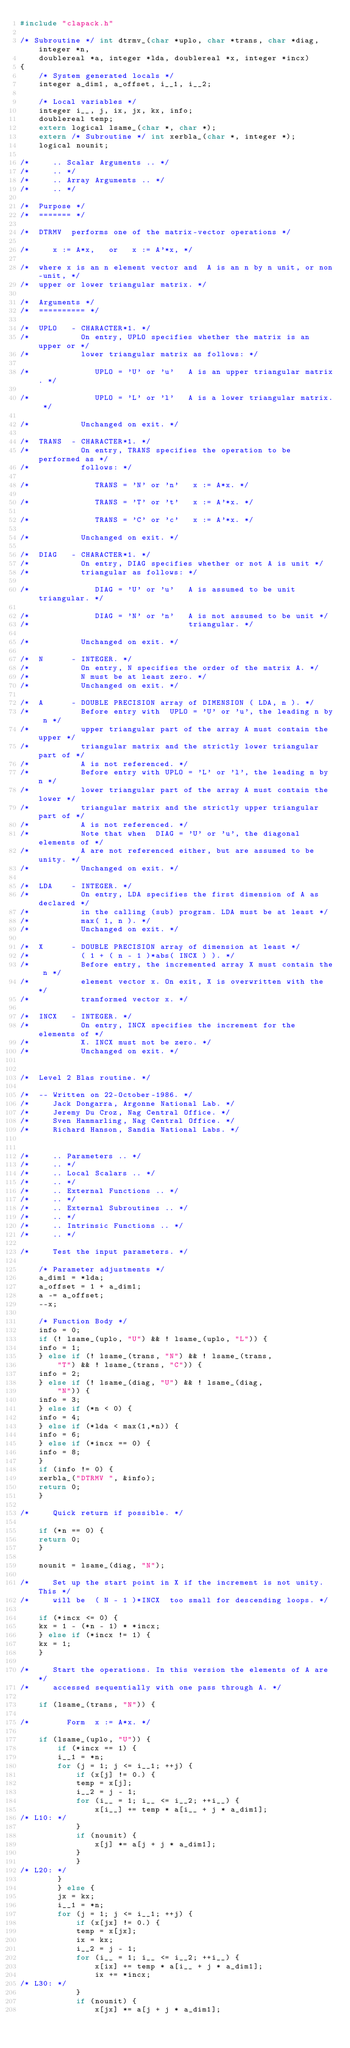<code> <loc_0><loc_0><loc_500><loc_500><_C_>#include "clapack.h"

/* Subroutine */ int dtrmv_(char *uplo, char *trans, char *diag, integer *n, 
	doublereal *a, integer *lda, doublereal *x, integer *incx)
{
    /* System generated locals */
    integer a_dim1, a_offset, i__1, i__2;

    /* Local variables */
    integer i__, j, ix, jx, kx, info;
    doublereal temp;
    extern logical lsame_(char *, char *);
    extern /* Subroutine */ int xerbla_(char *, integer *);
    logical nounit;

/*     .. Scalar Arguments .. */
/*     .. */
/*     .. Array Arguments .. */
/*     .. */

/*  Purpose */
/*  ======= */

/*  DTRMV  performs one of the matrix-vector operations */

/*     x := A*x,   or   x := A'*x, */

/*  where x is an n element vector and  A is an n by n unit, or non-unit, */
/*  upper or lower triangular matrix. */

/*  Arguments */
/*  ========== */

/*  UPLO   - CHARACTER*1. */
/*           On entry, UPLO specifies whether the matrix is an upper or */
/*           lower triangular matrix as follows: */

/*              UPLO = 'U' or 'u'   A is an upper triangular matrix. */

/*              UPLO = 'L' or 'l'   A is a lower triangular matrix. */

/*           Unchanged on exit. */

/*  TRANS  - CHARACTER*1. */
/*           On entry, TRANS specifies the operation to be performed as */
/*           follows: */

/*              TRANS = 'N' or 'n'   x := A*x. */

/*              TRANS = 'T' or 't'   x := A'*x. */

/*              TRANS = 'C' or 'c'   x := A'*x. */

/*           Unchanged on exit. */

/*  DIAG   - CHARACTER*1. */
/*           On entry, DIAG specifies whether or not A is unit */
/*           triangular as follows: */

/*              DIAG = 'U' or 'u'   A is assumed to be unit triangular. */

/*              DIAG = 'N' or 'n'   A is not assumed to be unit */
/*                                  triangular. */

/*           Unchanged on exit. */

/*  N      - INTEGER. */
/*           On entry, N specifies the order of the matrix A. */
/*           N must be at least zero. */
/*           Unchanged on exit. */

/*  A      - DOUBLE PRECISION array of DIMENSION ( LDA, n ). */
/*           Before entry with  UPLO = 'U' or 'u', the leading n by n */
/*           upper triangular part of the array A must contain the upper */
/*           triangular matrix and the strictly lower triangular part of */
/*           A is not referenced. */
/*           Before entry with UPLO = 'L' or 'l', the leading n by n */
/*           lower triangular part of the array A must contain the lower */
/*           triangular matrix and the strictly upper triangular part of */
/*           A is not referenced. */
/*           Note that when  DIAG = 'U' or 'u', the diagonal elements of */
/*           A are not referenced either, but are assumed to be unity. */
/*           Unchanged on exit. */

/*  LDA    - INTEGER. */
/*           On entry, LDA specifies the first dimension of A as declared */
/*           in the calling (sub) program. LDA must be at least */
/*           max( 1, n ). */
/*           Unchanged on exit. */

/*  X      - DOUBLE PRECISION array of dimension at least */
/*           ( 1 + ( n - 1 )*abs( INCX ) ). */
/*           Before entry, the incremented array X must contain the n */
/*           element vector x. On exit, X is overwritten with the */
/*           tranformed vector x. */

/*  INCX   - INTEGER. */
/*           On entry, INCX specifies the increment for the elements of */
/*           X. INCX must not be zero. */
/*           Unchanged on exit. */


/*  Level 2 Blas routine. */

/*  -- Written on 22-October-1986. */
/*     Jack Dongarra, Argonne National Lab. */
/*     Jeremy Du Croz, Nag Central Office. */
/*     Sven Hammarling, Nag Central Office. */
/*     Richard Hanson, Sandia National Labs. */


/*     .. Parameters .. */
/*     .. */
/*     .. Local Scalars .. */
/*     .. */
/*     .. External Functions .. */
/*     .. */
/*     .. External Subroutines .. */
/*     .. */
/*     .. Intrinsic Functions .. */
/*     .. */

/*     Test the input parameters. */

    /* Parameter adjustments */
    a_dim1 = *lda;
    a_offset = 1 + a_dim1;
    a -= a_offset;
    --x;

    /* Function Body */
    info = 0;
    if (! lsame_(uplo, "U") && ! lsame_(uplo, "L")) {
	info = 1;
    } else if (! lsame_(trans, "N") && ! lsame_(trans, 
	    "T") && ! lsame_(trans, "C")) {
	info = 2;
    } else if (! lsame_(diag, "U") && ! lsame_(diag, 
	    "N")) {
	info = 3;
    } else if (*n < 0) {
	info = 4;
    } else if (*lda < max(1,*n)) {
	info = 6;
    } else if (*incx == 0) {
	info = 8;
    }
    if (info != 0) {
	xerbla_("DTRMV ", &info);
	return 0;
    }

/*     Quick return if possible. */

    if (*n == 0) {
	return 0;
    }

    nounit = lsame_(diag, "N");

/*     Set up the start point in X if the increment is not unity. This */
/*     will be  ( N - 1 )*INCX  too small for descending loops. */

    if (*incx <= 0) {
	kx = 1 - (*n - 1) * *incx;
    } else if (*incx != 1) {
	kx = 1;
    }

/*     Start the operations. In this version the elements of A are */
/*     accessed sequentially with one pass through A. */

    if (lsame_(trans, "N")) {

/*        Form  x := A*x. */

	if (lsame_(uplo, "U")) {
	    if (*incx == 1) {
		i__1 = *n;
		for (j = 1; j <= i__1; ++j) {
		    if (x[j] != 0.) {
			temp = x[j];
			i__2 = j - 1;
			for (i__ = 1; i__ <= i__2; ++i__) {
			    x[i__] += temp * a[i__ + j * a_dim1];
/* L10: */
			}
			if (nounit) {
			    x[j] *= a[j + j * a_dim1];
			}
		    }
/* L20: */
		}
	    } else {
		jx = kx;
		i__1 = *n;
		for (j = 1; j <= i__1; ++j) {
		    if (x[jx] != 0.) {
			temp = x[jx];
			ix = kx;
			i__2 = j - 1;
			for (i__ = 1; i__ <= i__2; ++i__) {
			    x[ix] += temp * a[i__ + j * a_dim1];
			    ix += *incx;
/* L30: */
			}
			if (nounit) {
			    x[jx] *= a[j + j * a_dim1];</code> 